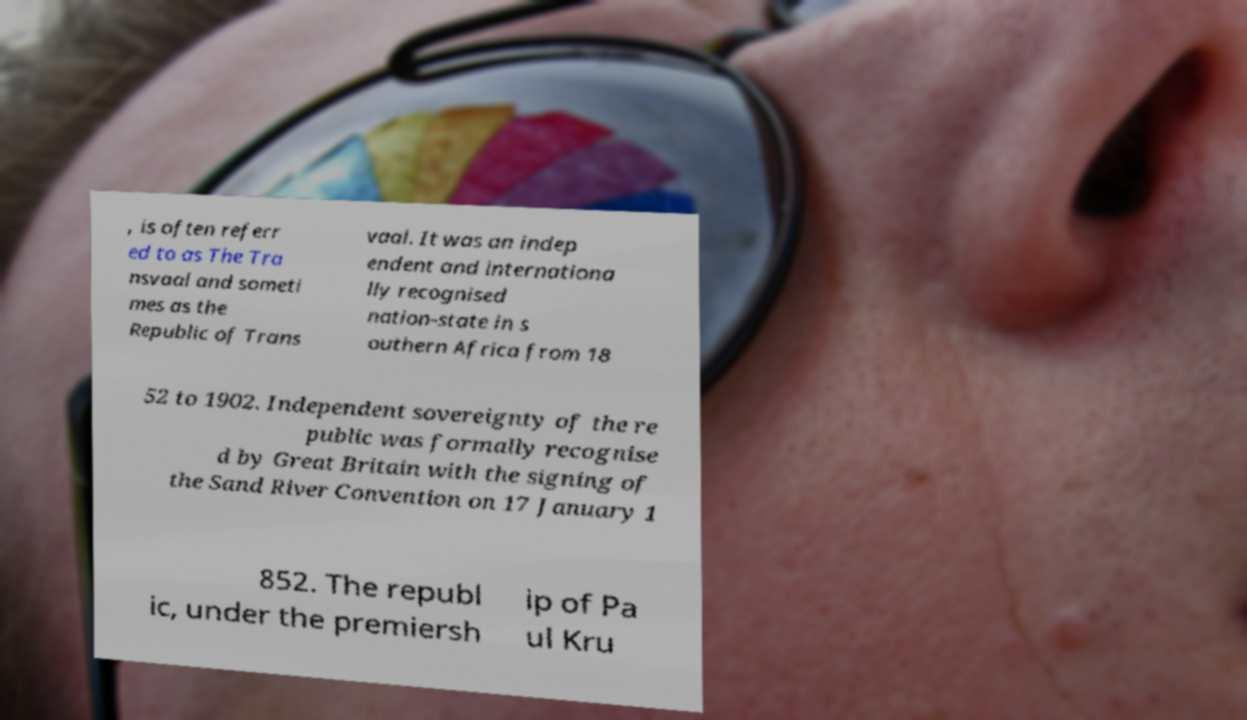I need the written content from this picture converted into text. Can you do that? , is often referr ed to as The Tra nsvaal and someti mes as the Republic of Trans vaal. It was an indep endent and internationa lly recognised nation-state in s outhern Africa from 18 52 to 1902. Independent sovereignty of the re public was formally recognise d by Great Britain with the signing of the Sand River Convention on 17 January 1 852. The republ ic, under the premiersh ip of Pa ul Kru 